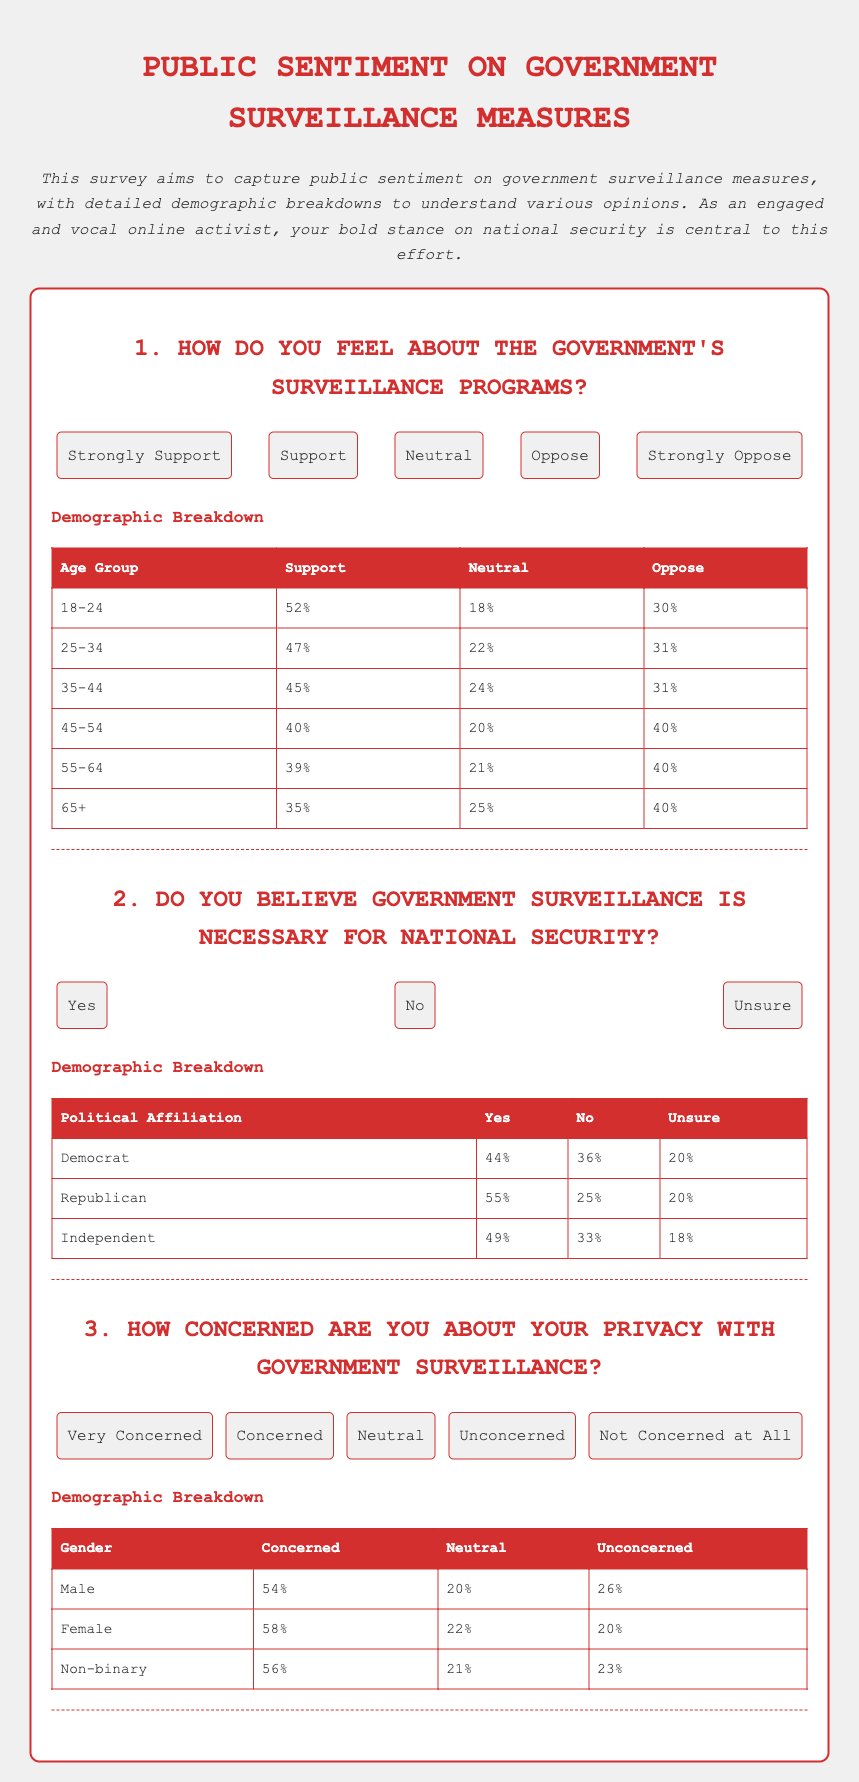What percentage of the 18-24 age group supports government surveillance programs? The percentage of the 18-24 age group that supports government surveillance programs is listed in the demographic breakdown table under that age group.
Answer: 52% What is the political affiliation with the highest percentage of people believing government surveillance is necessary? The political affiliation with the highest percentage believing that government surveillance is necessary for national security is indicated in the demographic breakdown table.
Answer: Republican What percentage of females are very concerned about their privacy with government surveillance? The percentage of females who are very concerned about their privacy is provided in the demographic section regarding gender.
Answer: 58% How many options are provided for feelings about government surveillance programs? The number of options for feelings about government surveillance programs can be counted from the list of options displayed in the question section.
Answer: 5 What is the percentage of Independents that are unsure about the necessity of government surveillance for national security? The percentage of Independents who are unsure is mentioned in the demographic breakdown table for political affiliation.
Answer: 18% What percentage of the 45-54 age group opposes government surveillance programs? The percentage who oppose government surveillance programs is specified in the demographic breakdown table for that age group.
Answer: 40% How many total questions are there in the survey? The total number of questions can be counted from the document's main section where each question is listed.
Answer: 3 What is the overall sentiment in the summary about the government's surveillance measures? The overall sentiment about government's surveillance measures is expressed as a general opinion in the summary at the beginning of the document.
Answer: Public sentiment 